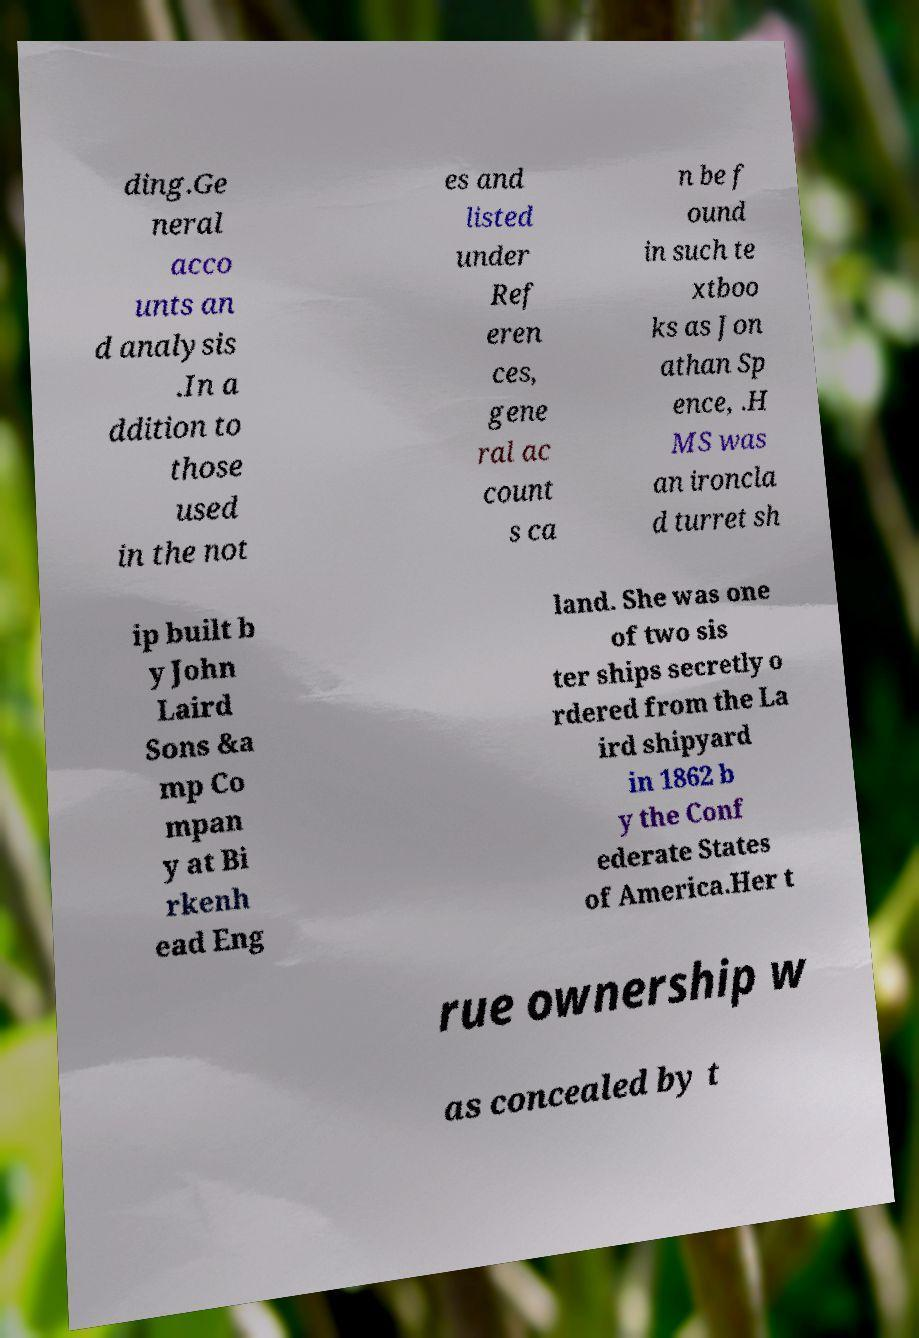For documentation purposes, I need the text within this image transcribed. Could you provide that? ding.Ge neral acco unts an d analysis .In a ddition to those used in the not es and listed under Ref eren ces, gene ral ac count s ca n be f ound in such te xtboo ks as Jon athan Sp ence, .H MS was an ironcla d turret sh ip built b y John Laird Sons &a mp Co mpan y at Bi rkenh ead Eng land. She was one of two sis ter ships secretly o rdered from the La ird shipyard in 1862 b y the Conf ederate States of America.Her t rue ownership w as concealed by t 